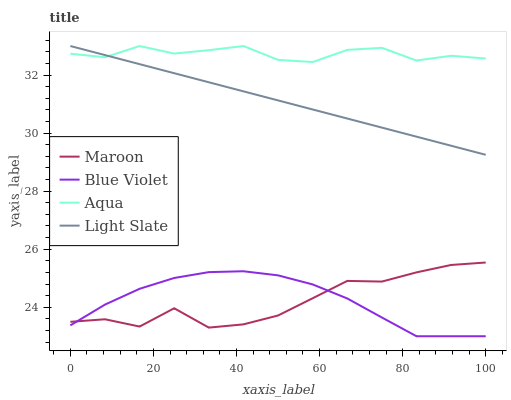Does Blue Violet have the minimum area under the curve?
Answer yes or no. No. Does Blue Violet have the maximum area under the curve?
Answer yes or no. No. Is Aqua the smoothest?
Answer yes or no. No. Is Aqua the roughest?
Answer yes or no. No. Does Aqua have the lowest value?
Answer yes or no. No. Does Blue Violet have the highest value?
Answer yes or no. No. Is Maroon less than Light Slate?
Answer yes or no. Yes. Is Light Slate greater than Maroon?
Answer yes or no. Yes. Does Maroon intersect Light Slate?
Answer yes or no. No. 